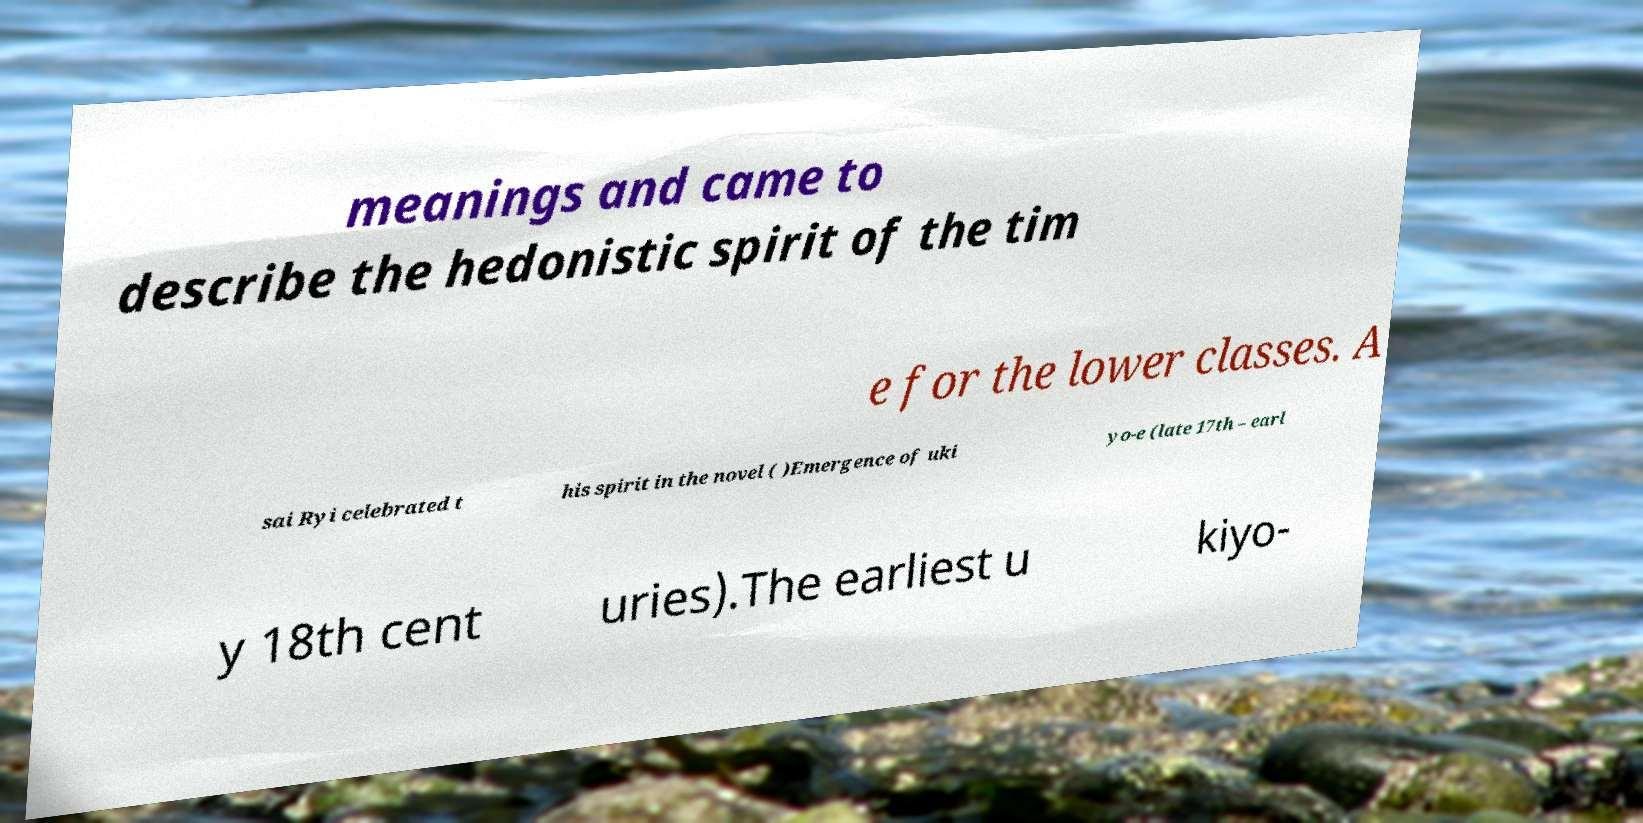Can you read and provide the text displayed in the image?This photo seems to have some interesting text. Can you extract and type it out for me? meanings and came to describe the hedonistic spirit of the tim e for the lower classes. A sai Ryi celebrated t his spirit in the novel ( )Emergence of uki yo-e (late 17th – earl y 18th cent uries).The earliest u kiyo- 